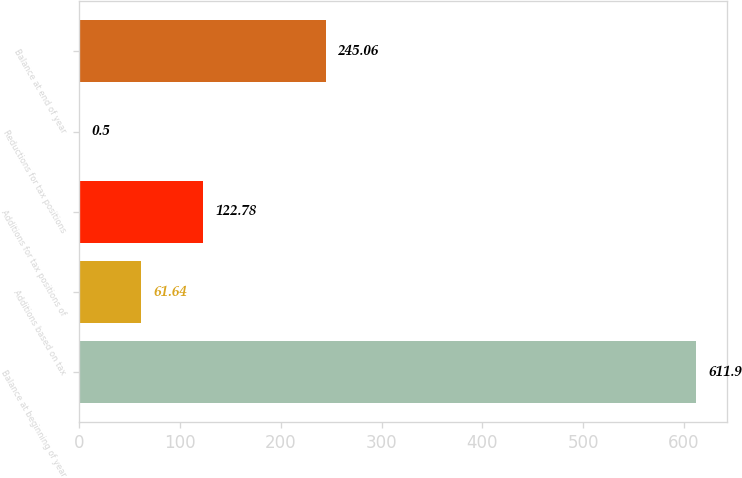Convert chart. <chart><loc_0><loc_0><loc_500><loc_500><bar_chart><fcel>Balance at beginning of year<fcel>Additions based on tax<fcel>Additions for tax positions of<fcel>Reductions for tax positions<fcel>Balance at end of year<nl><fcel>611.9<fcel>61.64<fcel>122.78<fcel>0.5<fcel>245.06<nl></chart> 